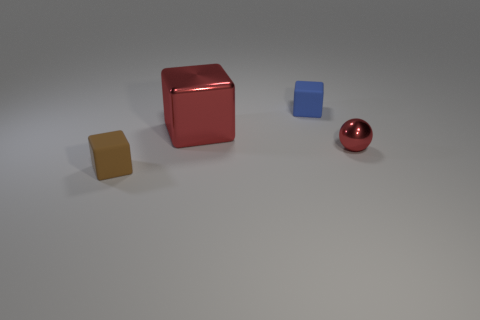Is there any other thing that is the same size as the red block?
Ensure brevity in your answer.  No. What number of small blue blocks are in front of the small cube in front of the tiny red thing?
Your answer should be compact. 0. There is a small thing that is in front of the big red object and right of the big object; what is its shape?
Offer a very short reply. Sphere. There is a small block that is behind the object on the right side of the rubber object behind the brown object; what is its material?
Provide a succinct answer. Rubber. What is the size of the shiny cube that is the same color as the small metal sphere?
Offer a terse response. Large. What material is the red cube?
Keep it short and to the point. Metal. Is the sphere made of the same material as the red object that is behind the small red ball?
Ensure brevity in your answer.  Yes. There is a tiny rubber thing on the left side of the rubber thing that is on the right side of the brown object; what color is it?
Provide a succinct answer. Brown. What size is the object that is both to the right of the brown rubber thing and in front of the large shiny object?
Provide a succinct answer. Small. How many other objects are there of the same shape as the tiny red metallic thing?
Give a very brief answer. 0. 